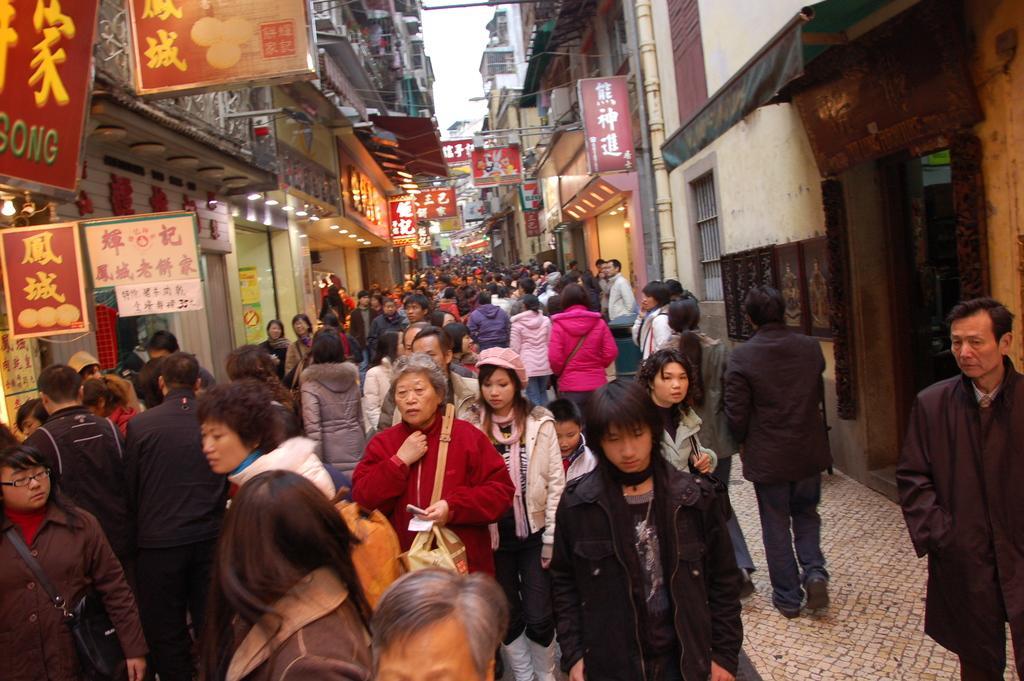Describe this image in one or two sentences. In the foreground of this image, there are people walking on the path. On either side, there are boards, buildings, lights and in the background, there is the sky. 